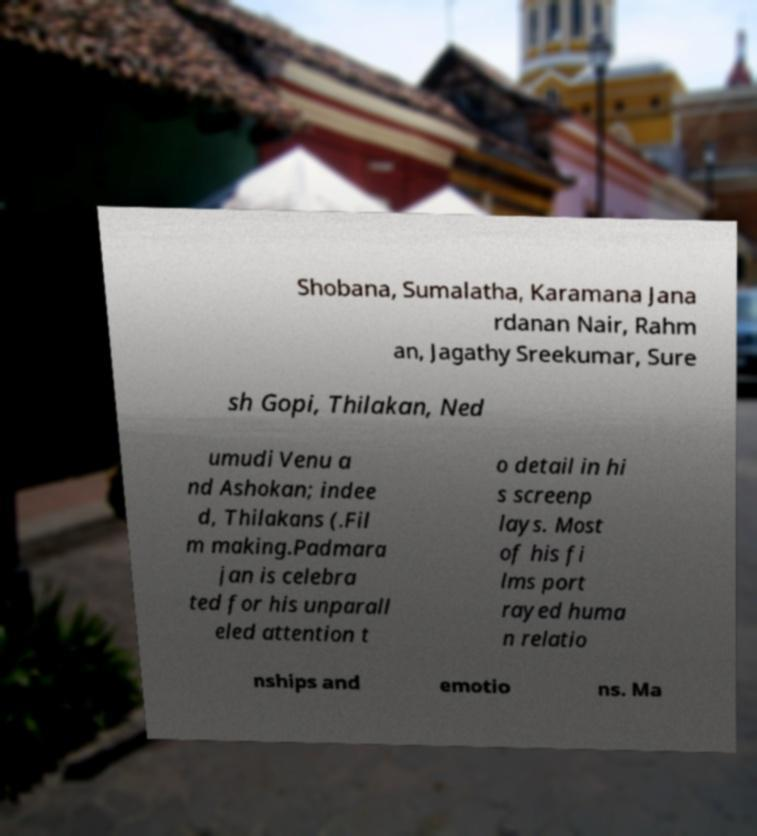Can you accurately transcribe the text from the provided image for me? Shobana, Sumalatha, Karamana Jana rdanan Nair, Rahm an, Jagathy Sreekumar, Sure sh Gopi, Thilakan, Ned umudi Venu a nd Ashokan; indee d, Thilakans (.Fil m making.Padmara jan is celebra ted for his unparall eled attention t o detail in hi s screenp lays. Most of his fi lms port rayed huma n relatio nships and emotio ns. Ma 